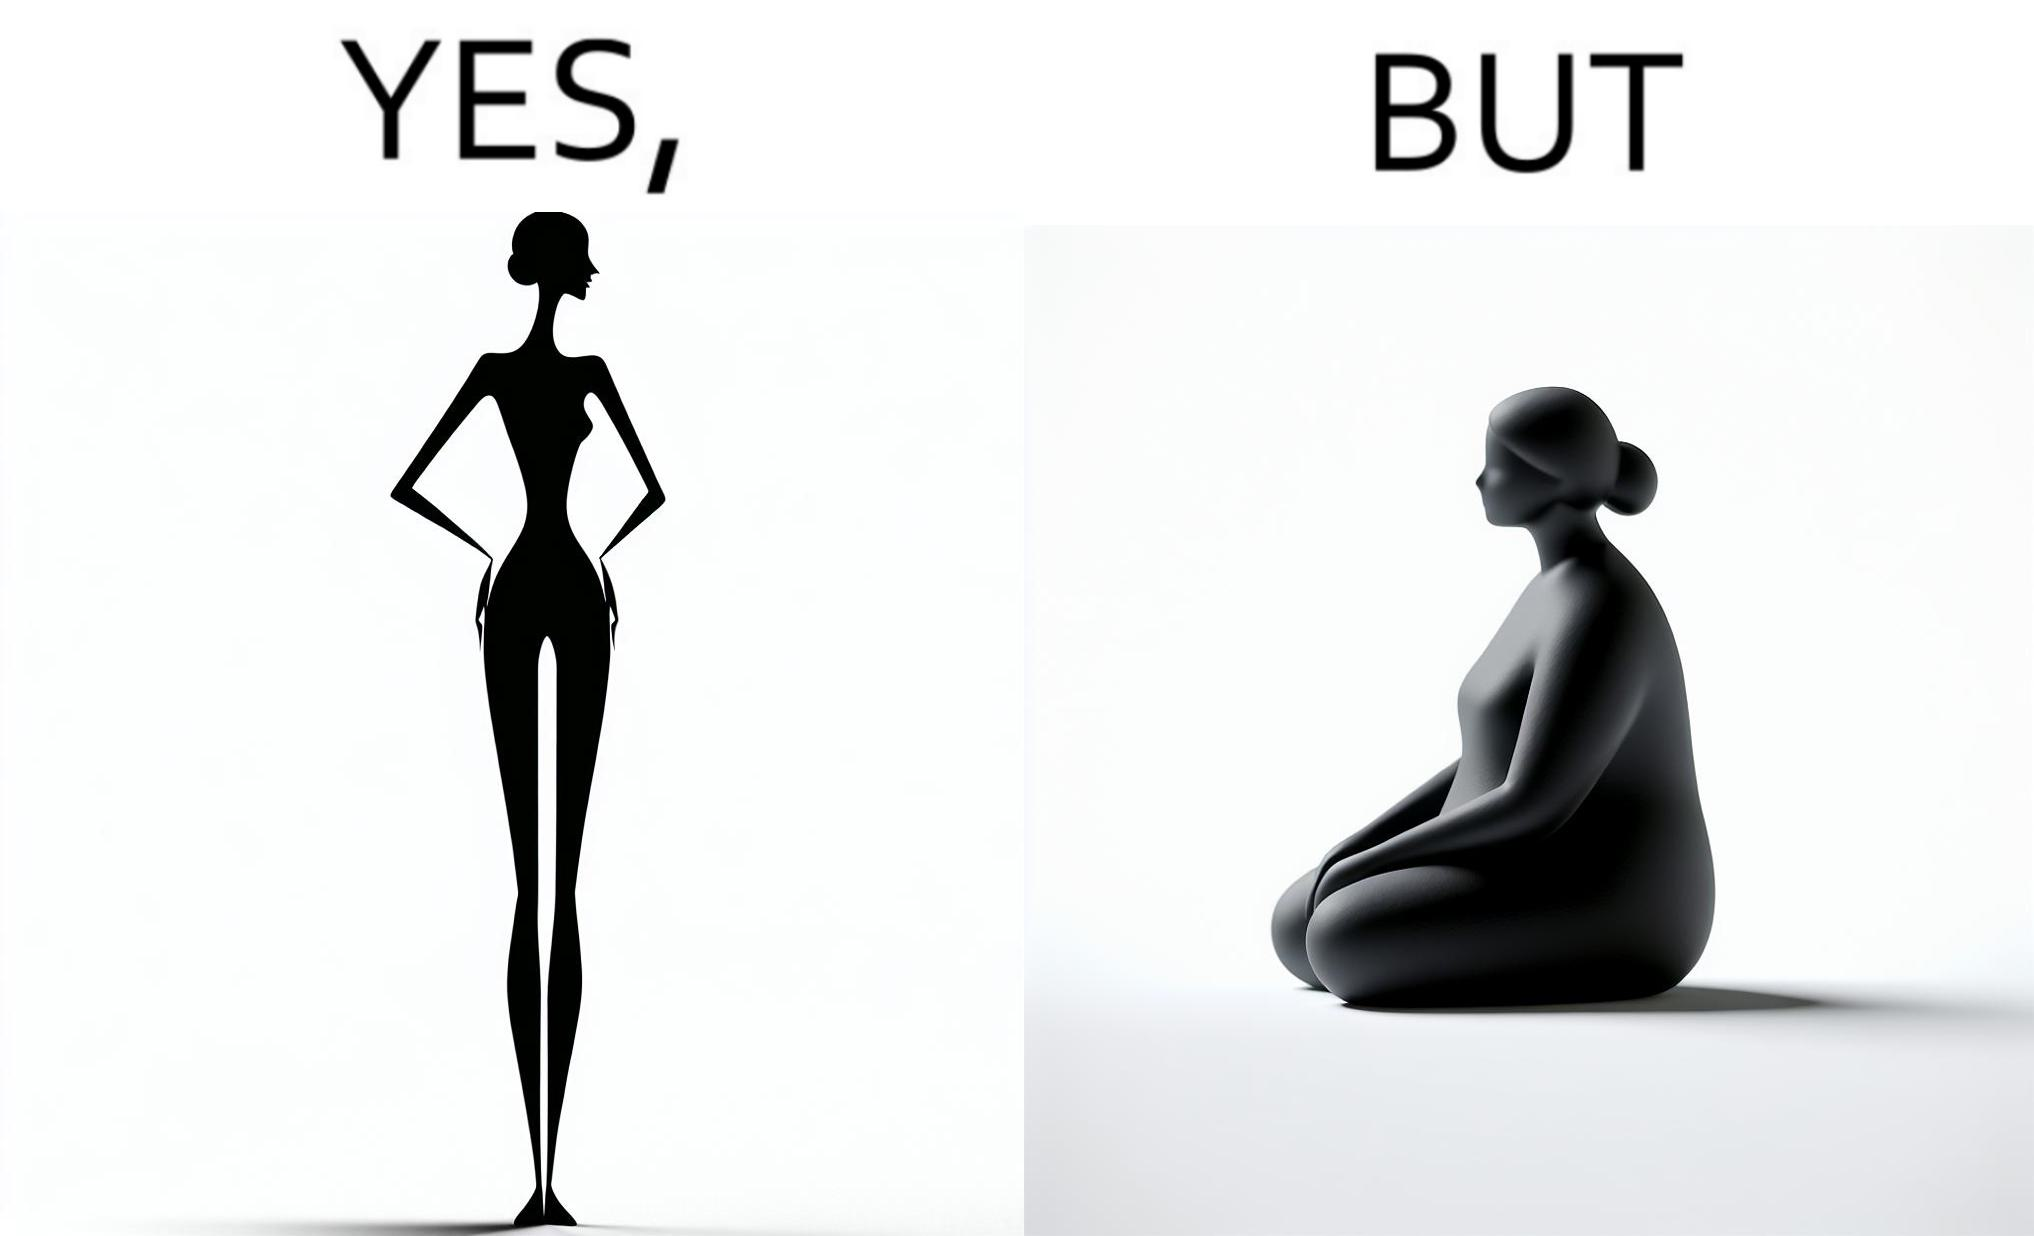Explain why this image is satirical. the image is funny, as from the front, the woman is apparently slim, but she looks chubby from the side. 